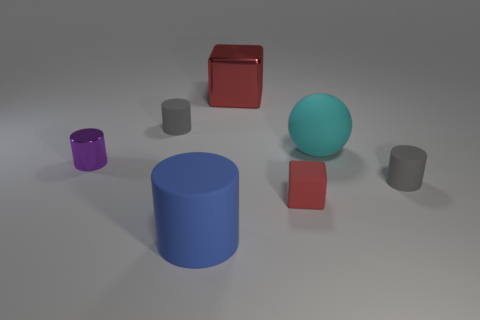Can you describe the colors of the cylindrical objects in the image? Certainly, in the image, there is one cylindrical object which is blue in color.  Are there any other objects in the scene with similar shapes? Aside from the blue cylinder, there are no other objects with a perfectly cylindrical shape. However, there are smaller cylinders that could be considered as cups or mugs, one in purple and another in a lighter gray. 